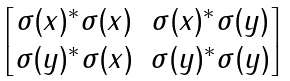Convert formula to latex. <formula><loc_0><loc_0><loc_500><loc_500>\begin{bmatrix} \sigma ( x ) ^ { * } \sigma ( x ) & \sigma ( x ) ^ { * } \sigma ( y ) \\ \sigma ( y ) ^ { * } \sigma ( x ) & \sigma ( y ) ^ { * } \sigma ( y ) \end{bmatrix}</formula> 